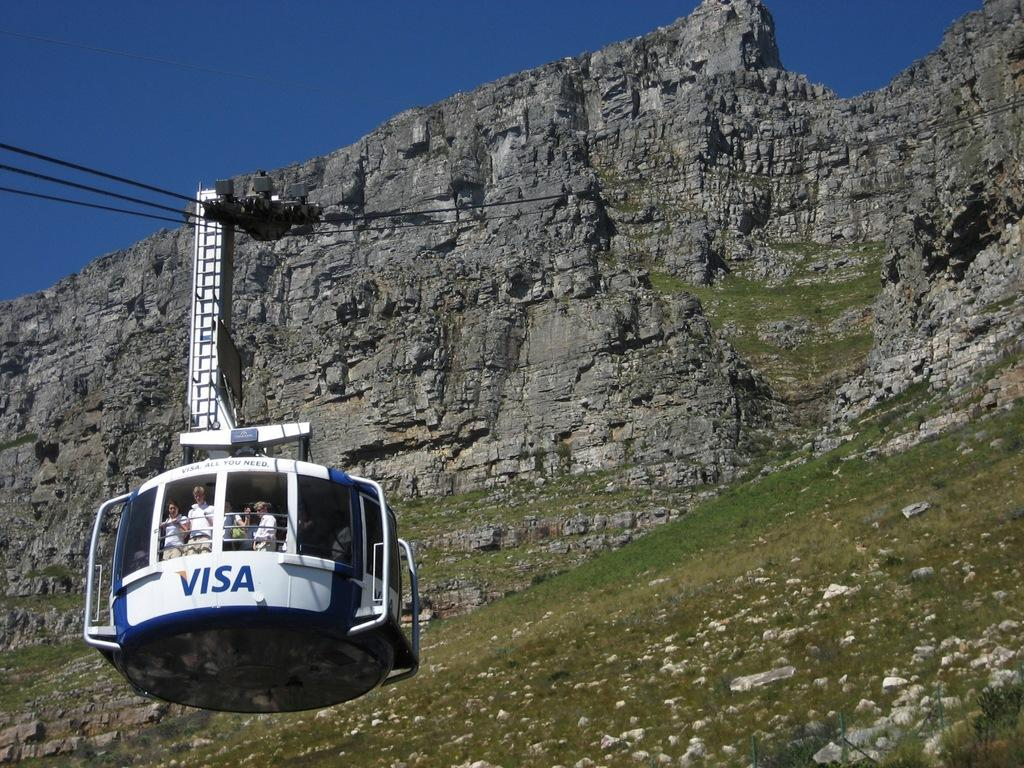What are the people in the image doing? The people are in a ropeway trolley in the image. What can be seen in the distance behind the trolley? There is a mountain in the background of the image. What else is visible in the background of the image? The sky and grass are visible in the background of the image, along with other objects. What type of bells are ringing in the image? There are no bells present in the image. 